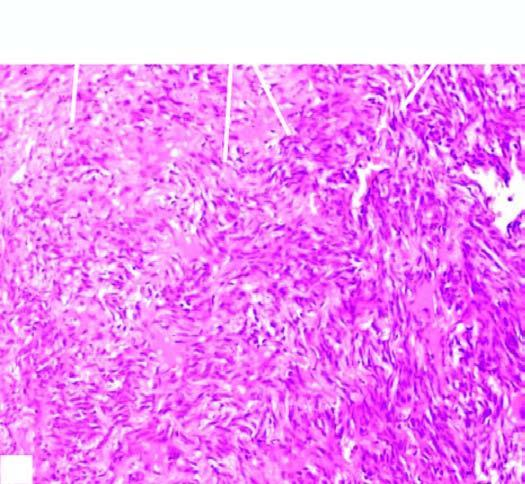does sectioned surface of the lung show replacement of slaty-grey spongy parenchyma with multiple, firm, grey-white nodular masses, some having areas of haemorhages and necrosis?
Answer the question using a single word or phrase. Yes 